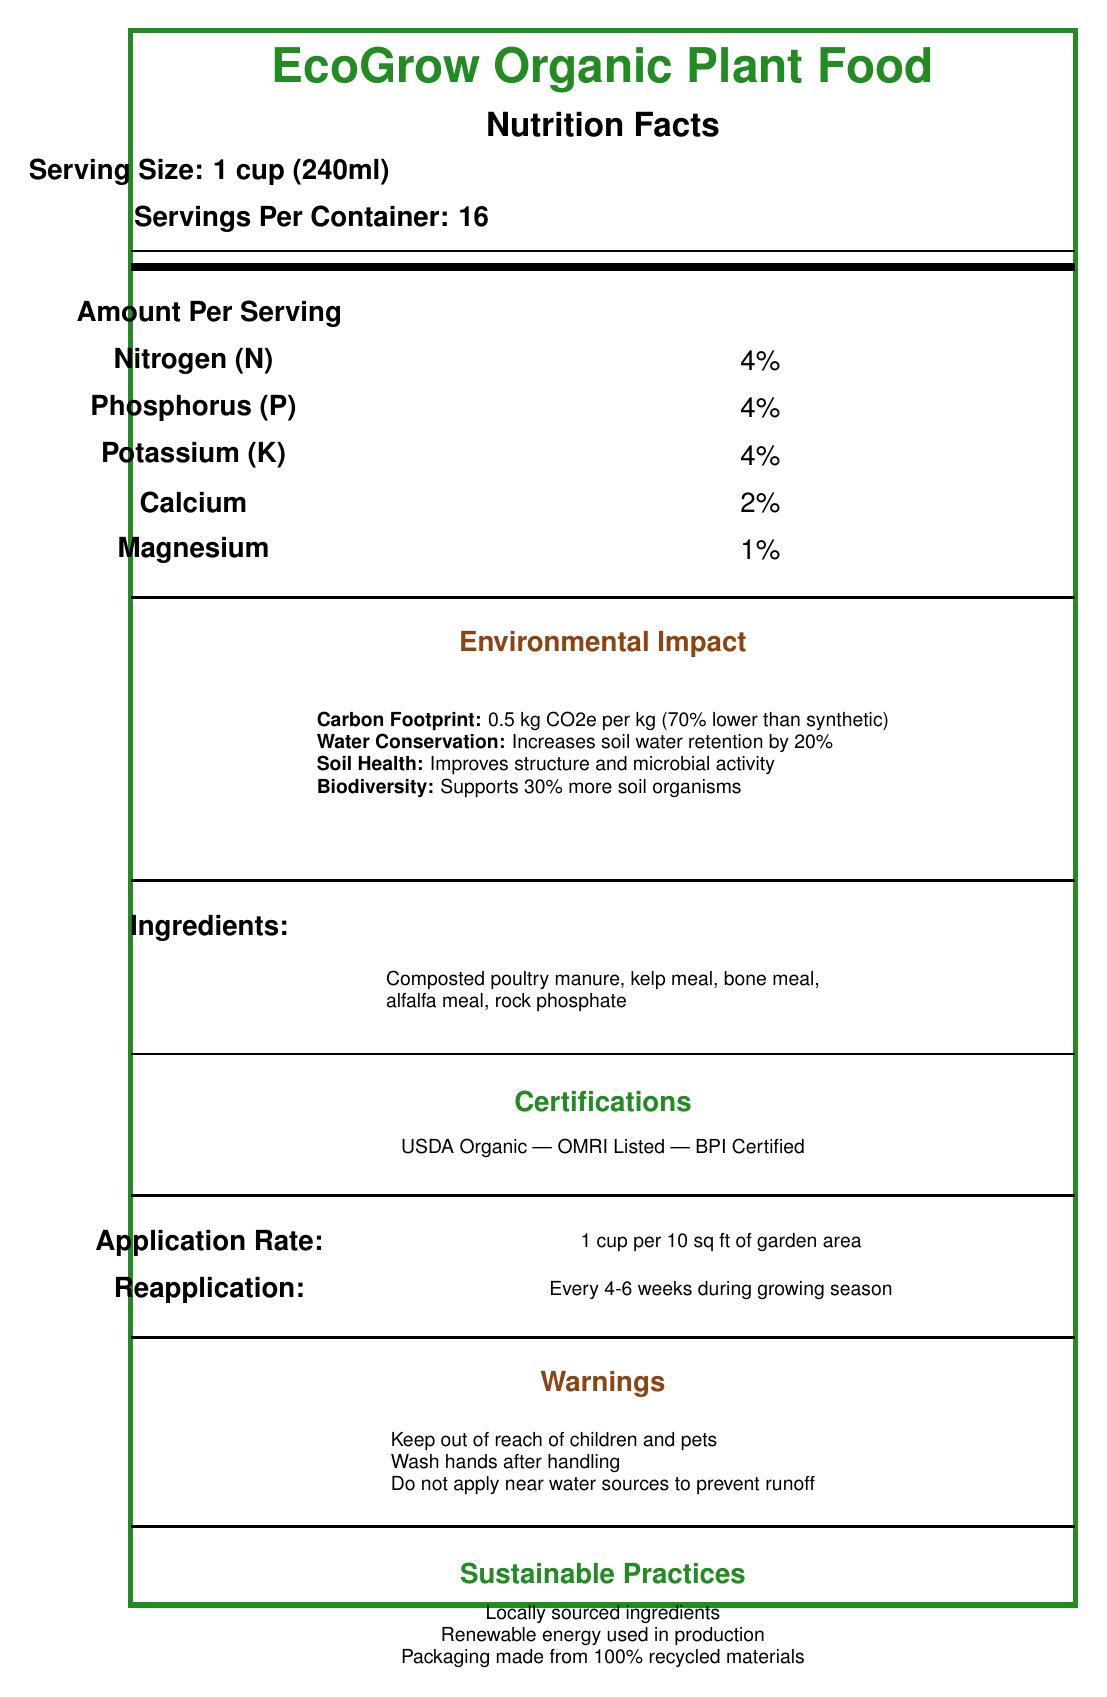What is the serving size for EcoGrow Organic Plant Food? The serving size is clearly stated as "Serving Size: 1 cup (240ml)" in the document.
Answer: 1 cup (240ml) How many servings are there per container of EcoGrow Organic Plant Food? The document states "Servings Per Container: 16".
Answer: 16 List the main nutrients provided by EcoGrow Organic Plant Food along with their percentages. The document details the nutrients and their respective amounts under the "Amount Per Serving" section.
Answer: Nitrogen (N) - 4%, Phosphorus (P) - 4%, Potassium (K) - 4%, Calcium - 2%, Magnesium - 1% What is the carbon footprint of EcoGrow Organic Plant Food? How does it compare to synthetic fertilizers? The "Environmental Impact" section specifies the carbon footprint as "0.5 kg CO2e per kg of product" and compares it to synthetic fertilizers, being "70% lower".
Answer: 0.5 kg CO2e per kg; 70% lower than synthetic fertilizers What are the recommended conditions for storing EcoGrow Organic Plant Food? The "shelf life" section states that the product lasts 2 years when stored in a cool, dry place.
Answer: Cool, dry place What sustainable practices are associated with EcoGrow Organic Plant Food?   A. Use of synthetic materials   B. Packaging made from 100% recycled materials   C. Locally sourced ingredients   D. Renewable energy used in production   E. Both B and C The document lists "Locally sourced ingredients," "Renewable energy used in production," and "Packaging made from 100% recycled materials" as sustainable practices.
Answer: E Which of the following certifications does EcoGrow Organic Plant Food hold? A. Non-GMO Project   B. USDA Organic   C. OMRI Listed   D. BPI Certified The document shows that the product is certified with "USDA Organic", "OMRI Listed", and "BPI Certified".
Answer: B, C, D Can EcoGrow Organic Plant Food be used for herbs? The "plant types" section includes "Herbs" as one of the suitable plant types for this product.
Answer: Yes Does EcoGrow Organic Plant Food improve soil health? The "Environmental Impact" section mentions that the product "Improves soil structure and microbial activity".
Answer: Yes Describe the main focus of the visual document. The document emphasizes the product's nutritional information, eco-friendly aspects, certifications, sustainability, and application guidelines, providing a comprehensive overview of the product.
Answer: The document provides detailed information about EcoGrow Organic Plant Food, including its nutrient content, environmental impact, ingredients, certifications, sustainable practices, application rate, reapplication frequency, shelf life, suitable plant types, and warnings. Is EcoGrow Organic Plant Food safe to apply near water sources? The warnings section clearly states "Do not apply near water sources to prevent runoff".
Answer: No What is the value of nitrogen in EcoGrow Organic Plant Food? Under the "Amount Per Serving" section, nitrogen is listed with an amount of 4%.
Answer: 4% How often should EcoGrow Organic Plant Food be reapplied during the growing season? The "Reapplication" section advises reapplication every 4-6 weeks during the growing season.
Answer: Every 4-6 weeks What is the primary ingredient in EcoGrow Organic Plant Food? The ingredients section lists "Composted poultry manure" first.
Answer: Composted poultry manure Does the document provide information on the product's price? The document does not discuss the pricing details of the EcoGrow Organic Plant Food.
Answer: Not enough information 